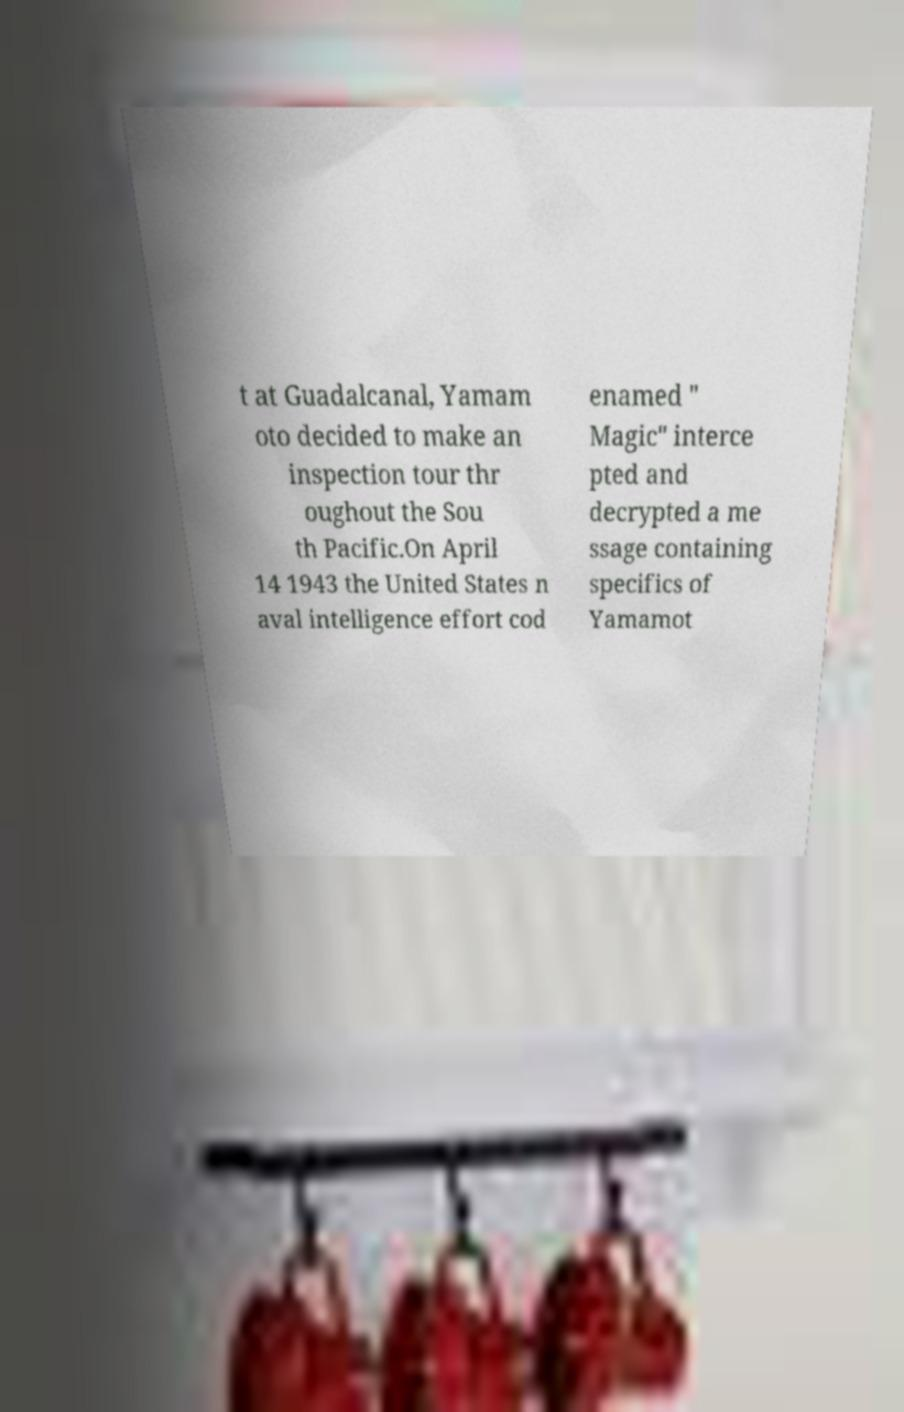Could you assist in decoding the text presented in this image and type it out clearly? t at Guadalcanal, Yamam oto decided to make an inspection tour thr oughout the Sou th Pacific.On April 14 1943 the United States n aval intelligence effort cod enamed " Magic" interce pted and decrypted a me ssage containing specifics of Yamamot 